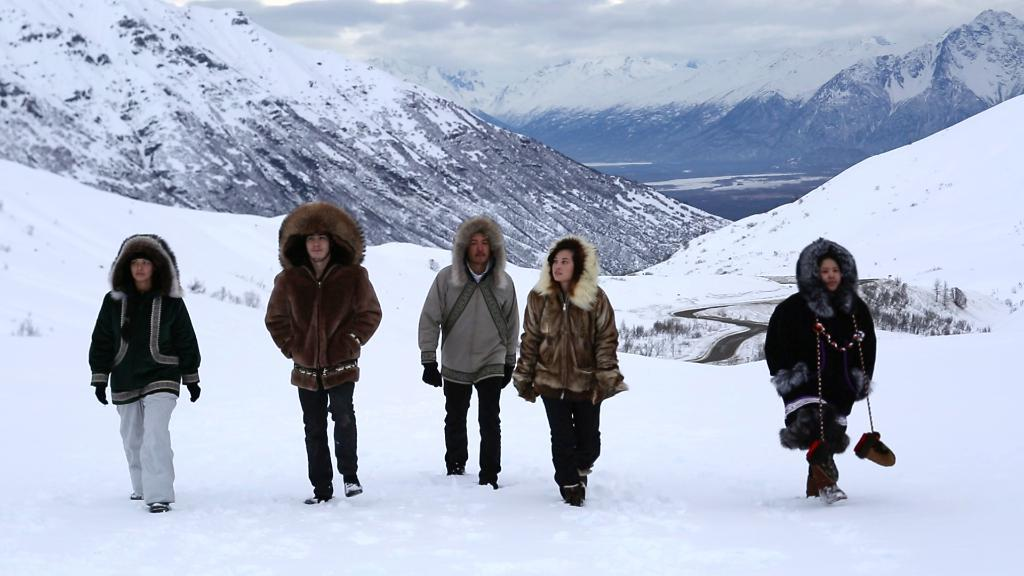Who or what is present in the image? There are people in the image. What are the people doing in the image? The people are walking on the snow. What are the people wearing in the image? The people are wearing jackets. What can be seen in the distance in the image? There are hills visible in the background of the image. How would you describe the weather in the image? The sky is cloudy in the background of the image, suggesting a potentially overcast or snowy day. What type of operation is being performed on the bee in the image? There is no bee present in the image, and therefore no operation is being performed on it. 